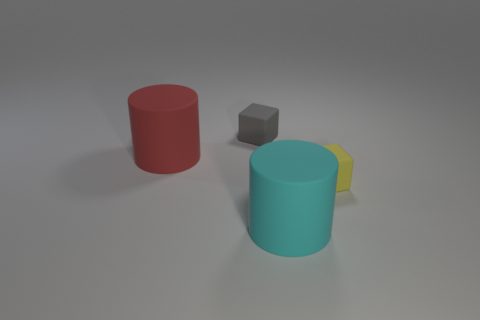Add 4 big yellow shiny cubes. How many objects exist? 8 Add 4 big rubber cylinders. How many big rubber cylinders are left? 6 Add 4 gray things. How many gray things exist? 5 Subtract 1 red cylinders. How many objects are left? 3 Subtract all red cylinders. Subtract all cyan balls. How many cylinders are left? 1 Subtract all small gray things. Subtract all small gray matte blocks. How many objects are left? 2 